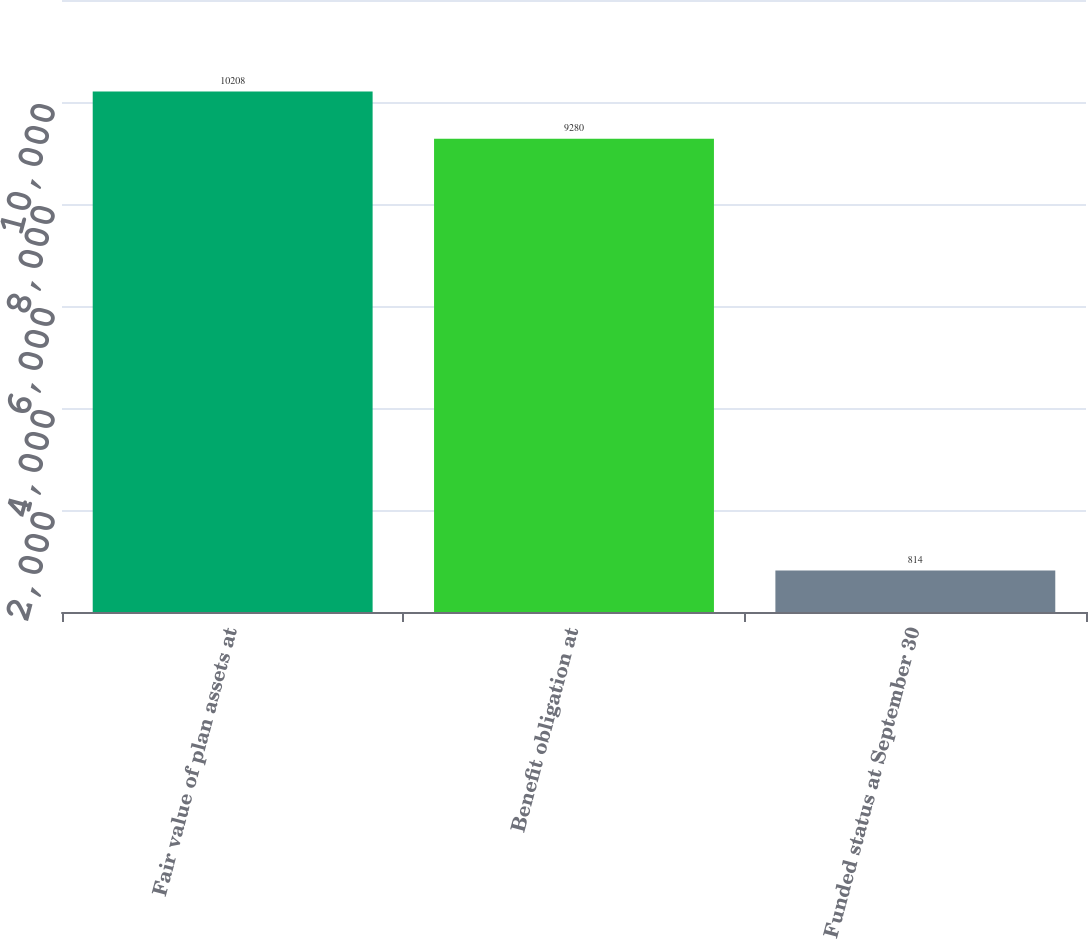<chart> <loc_0><loc_0><loc_500><loc_500><bar_chart><fcel>Fair value of plan assets at<fcel>Benefit obligation at<fcel>Funded status at September 30<nl><fcel>10208<fcel>9280<fcel>814<nl></chart> 